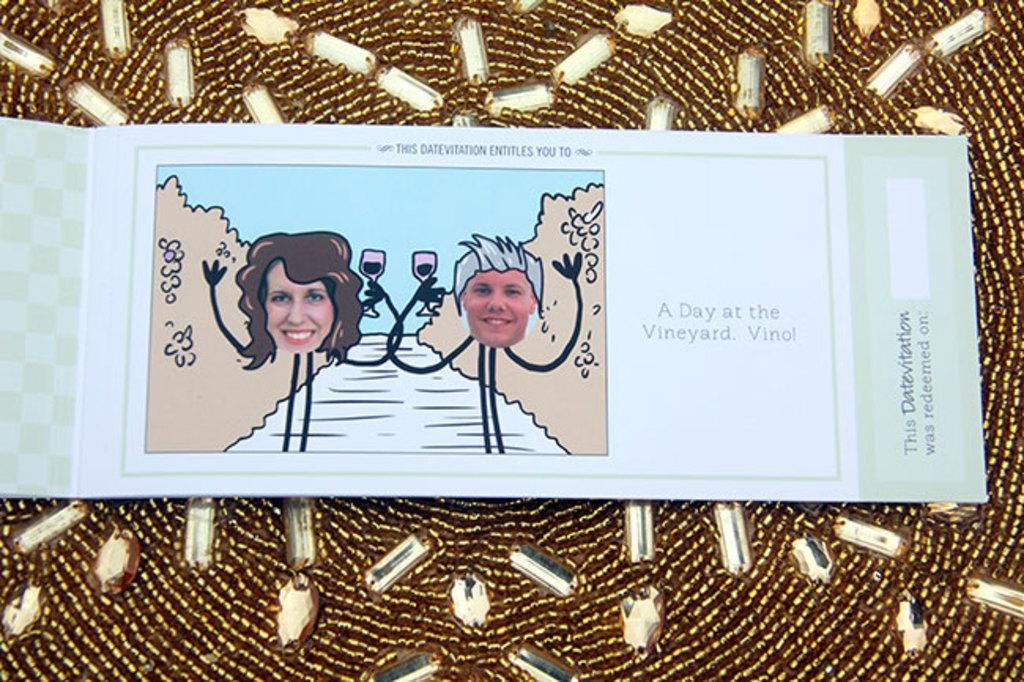What is the main object in the image? There is a book in the image. What can be found inside the book? The book contains text and pictures. How is the book positioned in the image? The book is placed on a decorated kundans cloth. What type of milk is being poured from the hand in the image? There is no milk or hand present in the image; it features a book placed on a decorated kundans cloth. How many lines can be seen in the image? The image does not show any lines; it features a book with text and pictures placed on a decorated kundans cloth. 